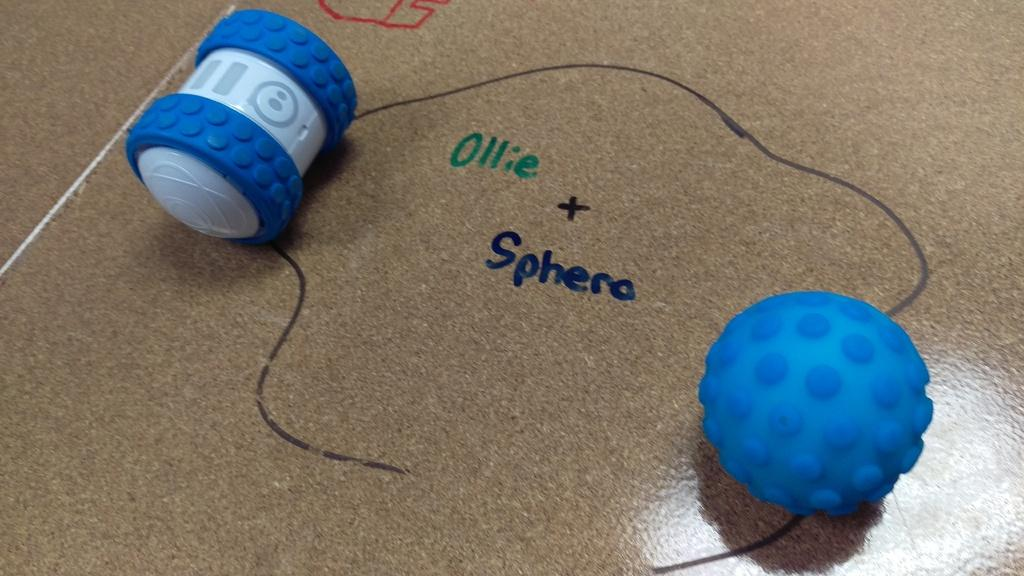Provide a one-sentence caption for the provided image. The words "Ollie & Sphero" written on a glossy tan surface. 